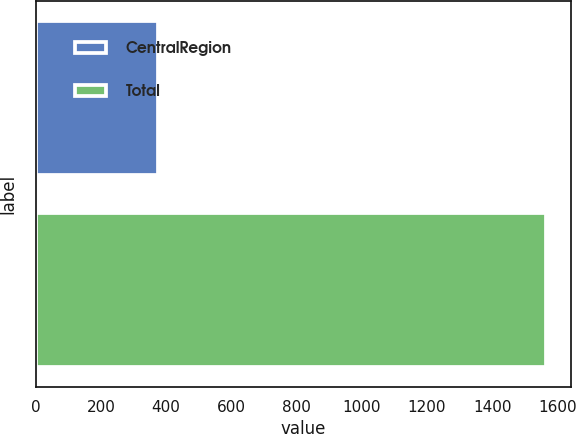<chart> <loc_0><loc_0><loc_500><loc_500><bar_chart><fcel>CentralRegion<fcel>Total<nl><fcel>374.1<fcel>1563.8<nl></chart> 